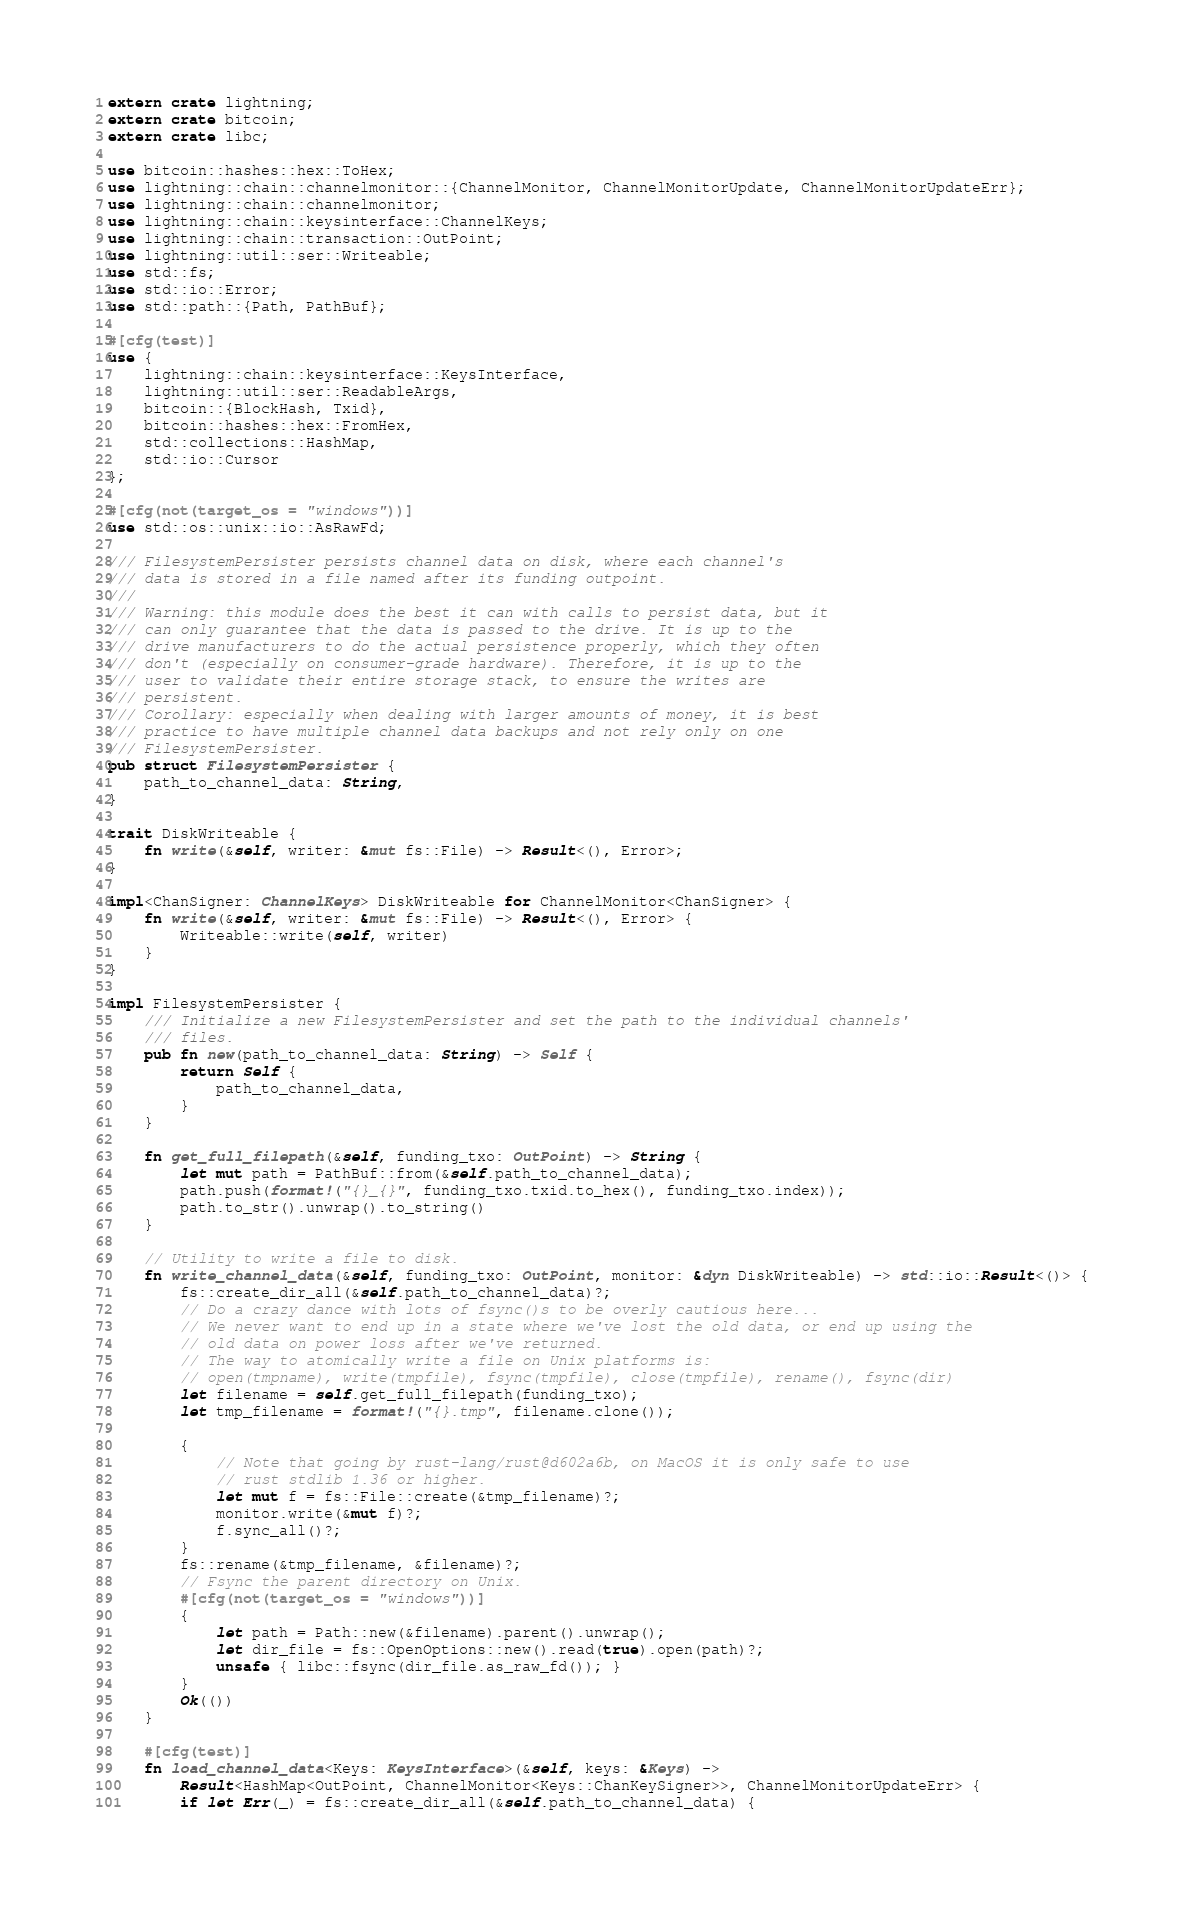<code> <loc_0><loc_0><loc_500><loc_500><_Rust_>extern crate lightning;
extern crate bitcoin;
extern crate libc;

use bitcoin::hashes::hex::ToHex;
use lightning::chain::channelmonitor::{ChannelMonitor, ChannelMonitorUpdate, ChannelMonitorUpdateErr};
use lightning::chain::channelmonitor;
use lightning::chain::keysinterface::ChannelKeys;
use lightning::chain::transaction::OutPoint;
use lightning::util::ser::Writeable;
use std::fs;
use std::io::Error;
use std::path::{Path, PathBuf};

#[cfg(test)]
use {
	lightning::chain::keysinterface::KeysInterface,
	lightning::util::ser::ReadableArgs,
	bitcoin::{BlockHash, Txid},
	bitcoin::hashes::hex::FromHex,
	std::collections::HashMap,
	std::io::Cursor
};

#[cfg(not(target_os = "windows"))]
use std::os::unix::io::AsRawFd;

/// FilesystemPersister persists channel data on disk, where each channel's
/// data is stored in a file named after its funding outpoint.
///
/// Warning: this module does the best it can with calls to persist data, but it
/// can only guarantee that the data is passed to the drive. It is up to the
/// drive manufacturers to do the actual persistence properly, which they often
/// don't (especially on consumer-grade hardware). Therefore, it is up to the
/// user to validate their entire storage stack, to ensure the writes are
/// persistent.
/// Corollary: especially when dealing with larger amounts of money, it is best
/// practice to have multiple channel data backups and not rely only on one
/// FilesystemPersister.
pub struct FilesystemPersister {
	path_to_channel_data: String,
}

trait DiskWriteable {
	fn write(&self, writer: &mut fs::File) -> Result<(), Error>;
}

impl<ChanSigner: ChannelKeys> DiskWriteable for ChannelMonitor<ChanSigner> {
	fn write(&self, writer: &mut fs::File) -> Result<(), Error> {
		Writeable::write(self, writer)
	}
}

impl FilesystemPersister {
	/// Initialize a new FilesystemPersister and set the path to the individual channels'
	/// files.
	pub fn new(path_to_channel_data: String) -> Self {
		return Self {
			path_to_channel_data,
		}
	}

	fn get_full_filepath(&self, funding_txo: OutPoint) -> String {
		let mut path = PathBuf::from(&self.path_to_channel_data);
		path.push(format!("{}_{}", funding_txo.txid.to_hex(), funding_txo.index));
		path.to_str().unwrap().to_string()
	}

	// Utility to write a file to disk.
	fn write_channel_data(&self, funding_txo: OutPoint, monitor: &dyn DiskWriteable) -> std::io::Result<()> {
		fs::create_dir_all(&self.path_to_channel_data)?;
		// Do a crazy dance with lots of fsync()s to be overly cautious here...
		// We never want to end up in a state where we've lost the old data, or end up using the
		// old data on power loss after we've returned.
		// The way to atomically write a file on Unix platforms is:
		// open(tmpname), write(tmpfile), fsync(tmpfile), close(tmpfile), rename(), fsync(dir)
		let filename = self.get_full_filepath(funding_txo);
		let tmp_filename = format!("{}.tmp", filename.clone());

		{
			// Note that going by rust-lang/rust@d602a6b, on MacOS it is only safe to use
			// rust stdlib 1.36 or higher.
			let mut f = fs::File::create(&tmp_filename)?;
			monitor.write(&mut f)?;
			f.sync_all()?;
		}
		fs::rename(&tmp_filename, &filename)?;
		// Fsync the parent directory on Unix.
		#[cfg(not(target_os = "windows"))]
		{
			let path = Path::new(&filename).parent().unwrap();
			let dir_file = fs::OpenOptions::new().read(true).open(path)?;
			unsafe { libc::fsync(dir_file.as_raw_fd()); }
		}
		Ok(())
	}

	#[cfg(test)]
	fn load_channel_data<Keys: KeysInterface>(&self, keys: &Keys) ->
		Result<HashMap<OutPoint, ChannelMonitor<Keys::ChanKeySigner>>, ChannelMonitorUpdateErr> {
		if let Err(_) = fs::create_dir_all(&self.path_to_channel_data) {</code> 